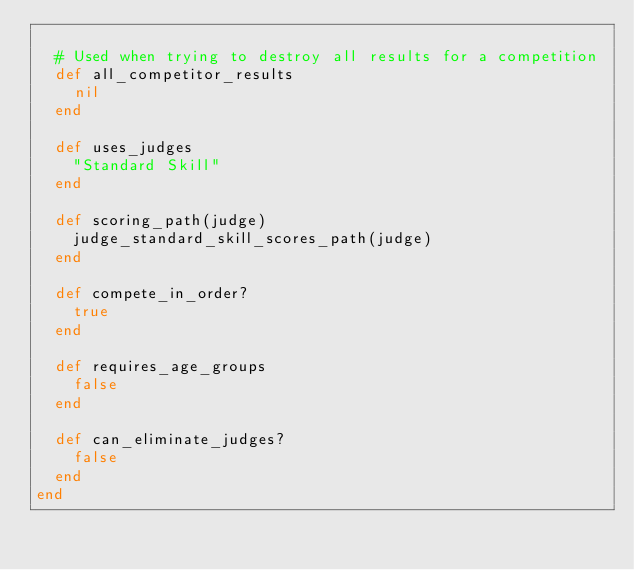Convert code to text. <code><loc_0><loc_0><loc_500><loc_500><_Ruby_>
  # Used when trying to destroy all results for a competition
  def all_competitor_results
    nil
  end

  def uses_judges
    "Standard Skill"
  end

  def scoring_path(judge)
    judge_standard_skill_scores_path(judge)
  end

  def compete_in_order?
    true
  end

  def requires_age_groups
    false
  end

  def can_eliminate_judges?
    false
  end
end
</code> 